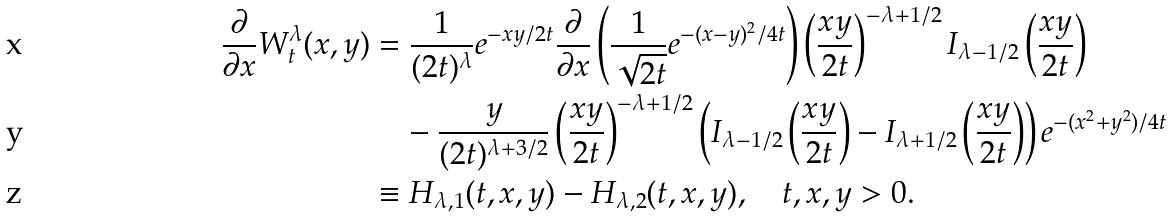<formula> <loc_0><loc_0><loc_500><loc_500>\frac { \partial } { \partial x } W _ { t } ^ { \lambda } ( x , y ) & = \frac { 1 } { ( 2 t ) ^ { \lambda } } e ^ { - x y / 2 t } \frac { \partial } { \partial x } \left ( \frac { 1 } { \sqrt { 2 t } } e ^ { - ( x - y ) ^ { 2 } / 4 t } \right ) \left ( \frac { x y } { 2 t } \right ) ^ { - \lambda + 1 / 2 } I _ { \lambda - 1 / 2 } \left ( \frac { x y } { 2 t } \right ) \\ & \quad - \frac { y } { ( 2 t ) ^ { \lambda + 3 / 2 } } \left ( \frac { x y } { 2 t } \right ) ^ { - \lambda + 1 \slash 2 } \left ( I _ { \lambda - 1 / 2 } \left ( \frac { x y } { 2 t } \right ) - I _ { \lambda + 1 / 2 } \left ( \frac { x y } { 2 t } \right ) \right ) e ^ { - ( x ^ { 2 } + y ^ { 2 } ) / 4 t } \\ & \equiv H _ { \lambda , 1 } ( t , x , y ) - H _ { \lambda , 2 } ( t , x , y ) , \quad t , x , y > 0 .</formula> 